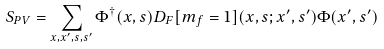Convert formula to latex. <formula><loc_0><loc_0><loc_500><loc_500>S _ { P V } = \sum _ { x , x ^ { \prime } , s , s ^ { \prime } } \Phi ^ { \dagger } ( x , s ) D _ { F } [ m _ { f } = 1 ] ( x , s ; x ^ { \prime } , s ^ { \prime } ) \Phi ( x ^ { \prime } , s ^ { \prime } )</formula> 